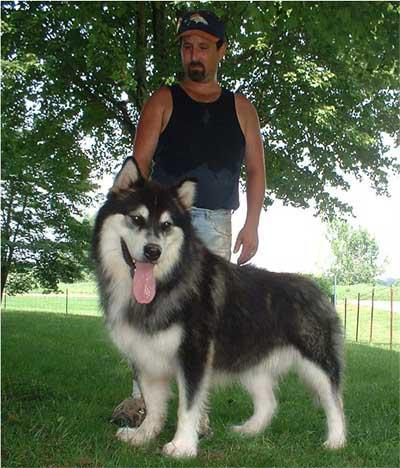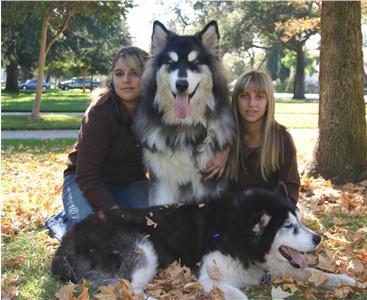The first image is the image on the left, the second image is the image on the right. Evaluate the accuracy of this statement regarding the images: "There are exactly two dogs and two people.". Is it true? Answer yes or no. No. The first image is the image on the left, the second image is the image on the right. Given the left and right images, does the statement "There are exactly two dogs in total." hold true? Answer yes or no. No. 